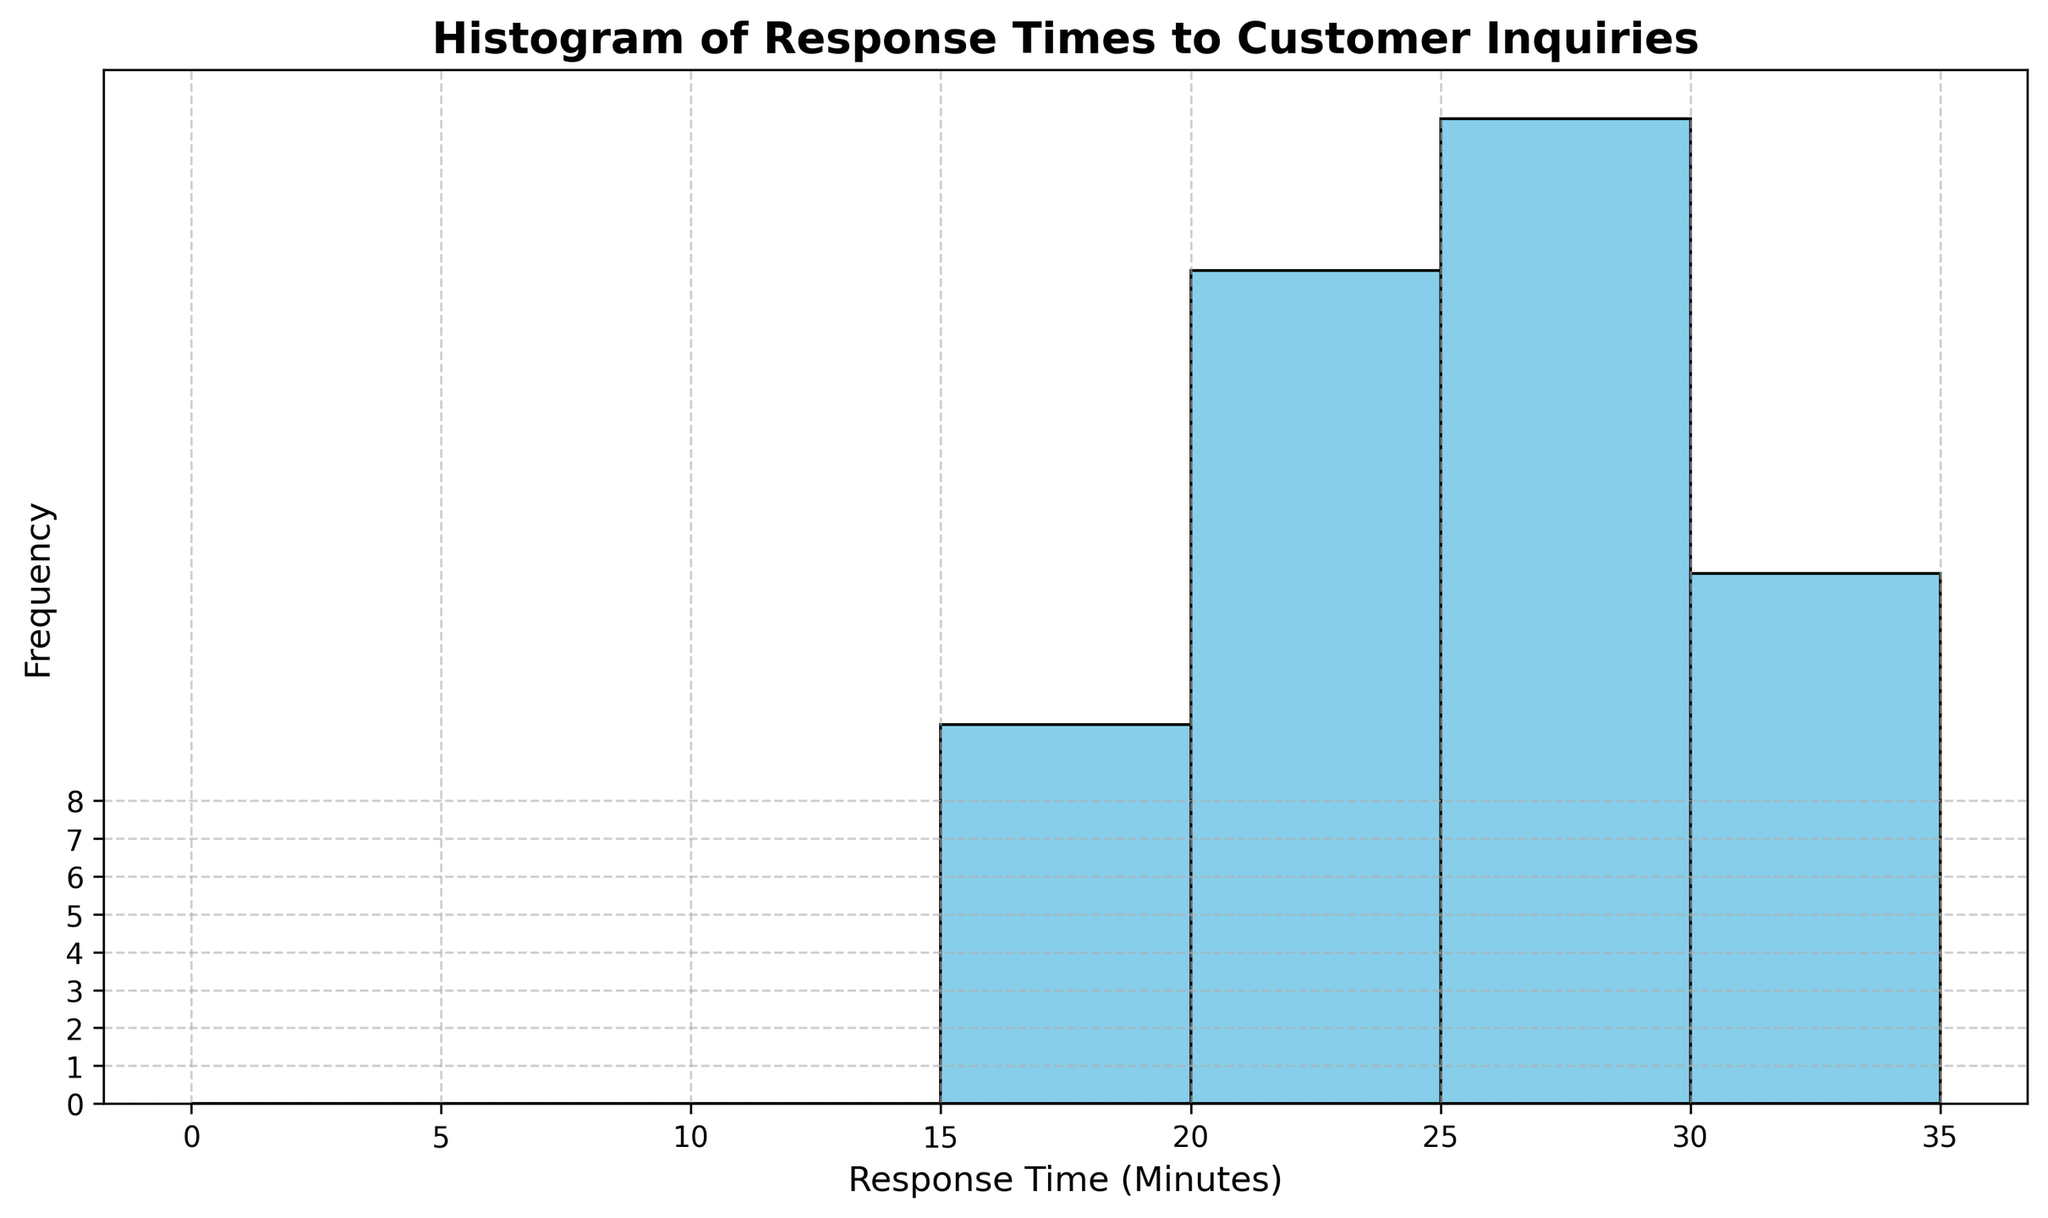What is the most common response time range? Looking at the histogram, identify the bin with the highest bar which indicates the most frequent range of response times. The highest bar is for the range 20-25 minutes.
Answer: 20-25 minutes What is the least common response time range? Find the smallest bar in the histogram. The smallest bar occurs at the range 35-40 minutes.
Answer: 35-40 minutes How many bins have more than 10 responses? Count the bins with bars extending above the frequency value of 10. There are three such bins: 20-25, 25-30, and 30-35 minutes.
Answer: 3 How many total inquiries had a response time between 10 and 20 minutes? Locate the bars corresponding to the intervals 10-15 and 15-20 minutes and sum their frequencies. There are no bins specifically visible within this range on this histogram, indicating a rare or zero frequency.
Answer: 0 What is the range of the response times shown in the histogram? Examine the lowest to highest value displayed on the x-axis of the histogram. The response times range from 0 to 35 minutes.
Answer: 0 to 35 minutes Which bin range has a higher frequency, 10-15 minutes or 30-35 minutes? Compare the height of the bins within the specified ranges. The frequency for 30-35 minutes is higher.
Answer: 30-35 minutes What is the frequency of inquiries with a response time of 25-30 minutes? Look at the bar representing the 25-30 minutes range and read off its height. The frequency is around 9.
Answer: 9 Between 15-20 minutes and 25-30 minutes, which one has a higher frequency and by how much? Compare the height of the bars for these ranges and calculate the difference. The 25-30 minute range has a higher frequency, with a difference of approximately 7.
Answer: 25-30 minutes by 7 What is the approximate average frequency of bins with intervals from 0 to 5, 5 to 10, and 10 to 15 minutes? Sum the frequencies of the specified bins and divide by the number of bins. The approximate sum for these bins is around 3 (0-5) + 0 (5-10) + 1.5 (10-15), and the average frequency is (3+0+1.5)/3 = 1.5.
Answer: 1.5 How many bins show a frequency less than 5? Count the number of bars in the histogram that have a height lower than 5. There are five such bins.
Answer: 5 